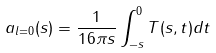Convert formula to latex. <formula><loc_0><loc_0><loc_500><loc_500>a _ { l = 0 } ( s ) = \frac { 1 } { 1 6 \pi s } \int _ { - s } ^ { 0 } T ( s , t ) d t</formula> 